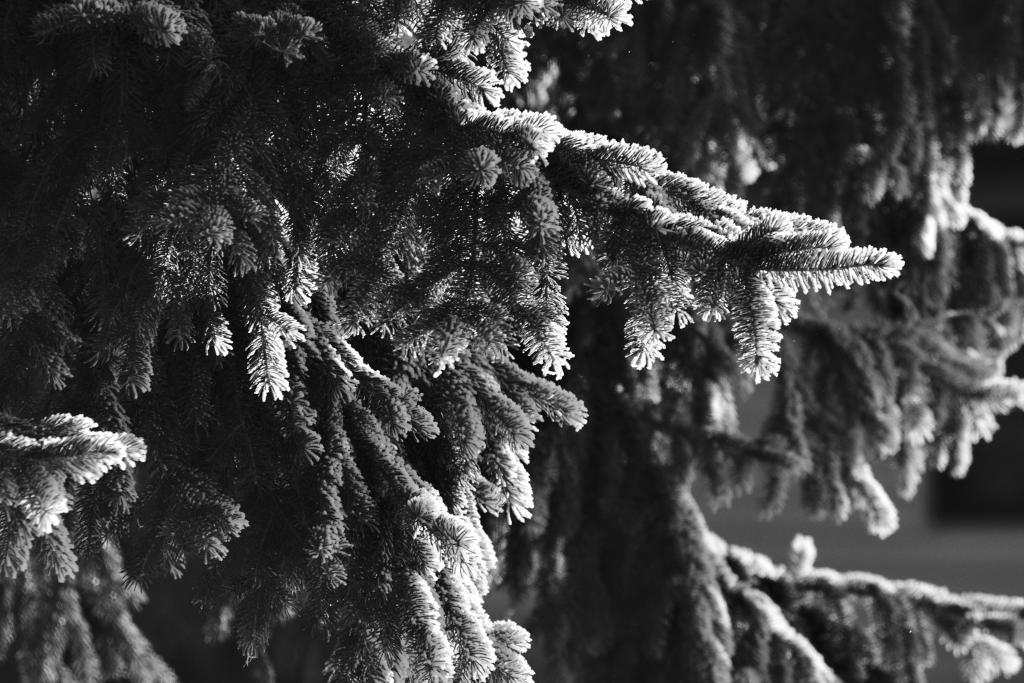What is the color scheme of the picture? The picture is black and white. What type of natural elements can be seen in the picture? There are trees in the picture. How many toothbrushes are hanging from the trees in the picture? There are no toothbrushes present in the picture; it only features trees. What is the weight of the person standing next to the trees in the picture? There is no person present in the picture, so their weight cannot be determined. 